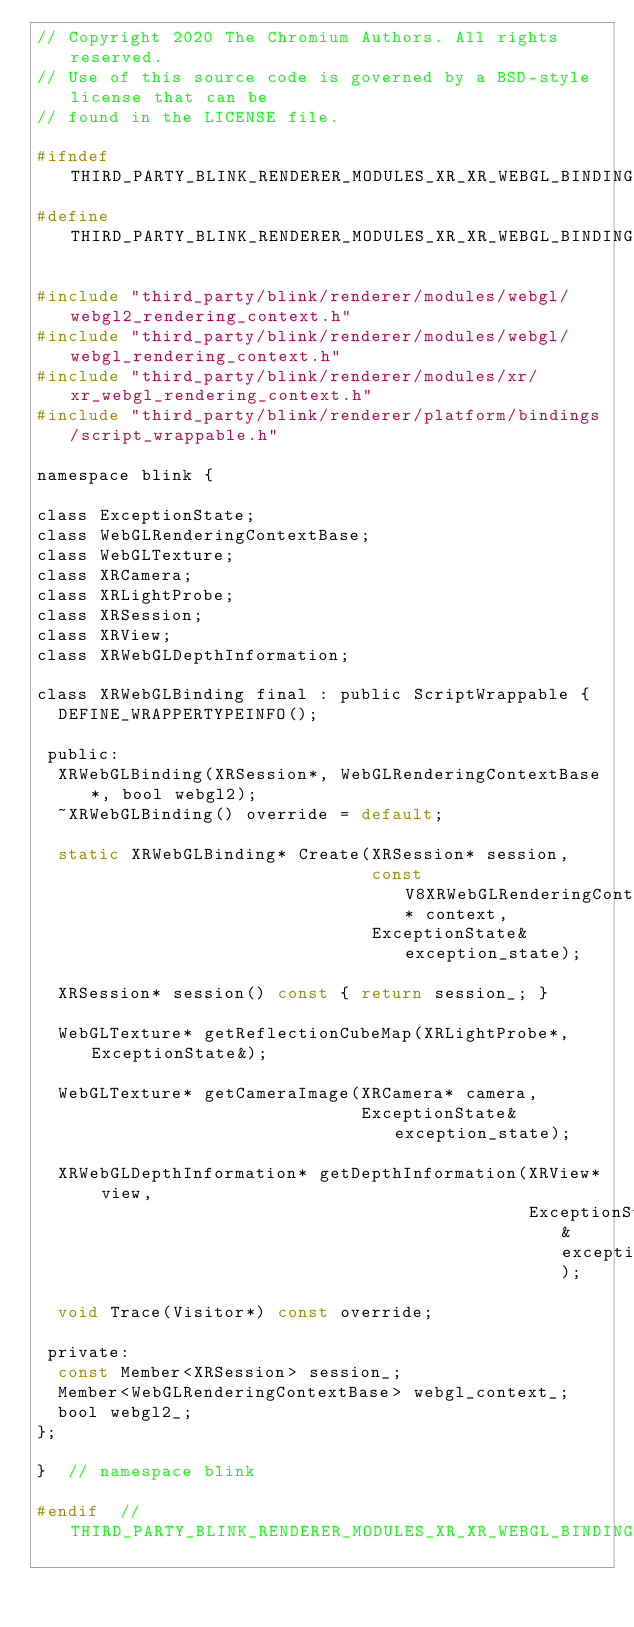Convert code to text. <code><loc_0><loc_0><loc_500><loc_500><_C_>// Copyright 2020 The Chromium Authors. All rights reserved.
// Use of this source code is governed by a BSD-style license that can be
// found in the LICENSE file.

#ifndef THIRD_PARTY_BLINK_RENDERER_MODULES_XR_XR_WEBGL_BINDING_H_
#define THIRD_PARTY_BLINK_RENDERER_MODULES_XR_XR_WEBGL_BINDING_H_

#include "third_party/blink/renderer/modules/webgl/webgl2_rendering_context.h"
#include "third_party/blink/renderer/modules/webgl/webgl_rendering_context.h"
#include "third_party/blink/renderer/modules/xr/xr_webgl_rendering_context.h"
#include "third_party/blink/renderer/platform/bindings/script_wrappable.h"

namespace blink {

class ExceptionState;
class WebGLRenderingContextBase;
class WebGLTexture;
class XRCamera;
class XRLightProbe;
class XRSession;
class XRView;
class XRWebGLDepthInformation;

class XRWebGLBinding final : public ScriptWrappable {
  DEFINE_WRAPPERTYPEINFO();

 public:
  XRWebGLBinding(XRSession*, WebGLRenderingContextBase*, bool webgl2);
  ~XRWebGLBinding() override = default;

  static XRWebGLBinding* Create(XRSession* session,
                                const V8XRWebGLRenderingContext* context,
                                ExceptionState& exception_state);

  XRSession* session() const { return session_; }

  WebGLTexture* getReflectionCubeMap(XRLightProbe*, ExceptionState&);

  WebGLTexture* getCameraImage(XRCamera* camera,
                               ExceptionState& exception_state);

  XRWebGLDepthInformation* getDepthInformation(XRView* view,
                                               ExceptionState& exception_state);

  void Trace(Visitor*) const override;

 private:
  const Member<XRSession> session_;
  Member<WebGLRenderingContextBase> webgl_context_;
  bool webgl2_;
};

}  // namespace blink

#endif  // THIRD_PARTY_BLINK_RENDERER_MODULES_XR_XR_WEBGL_BINDING_H_
</code> 